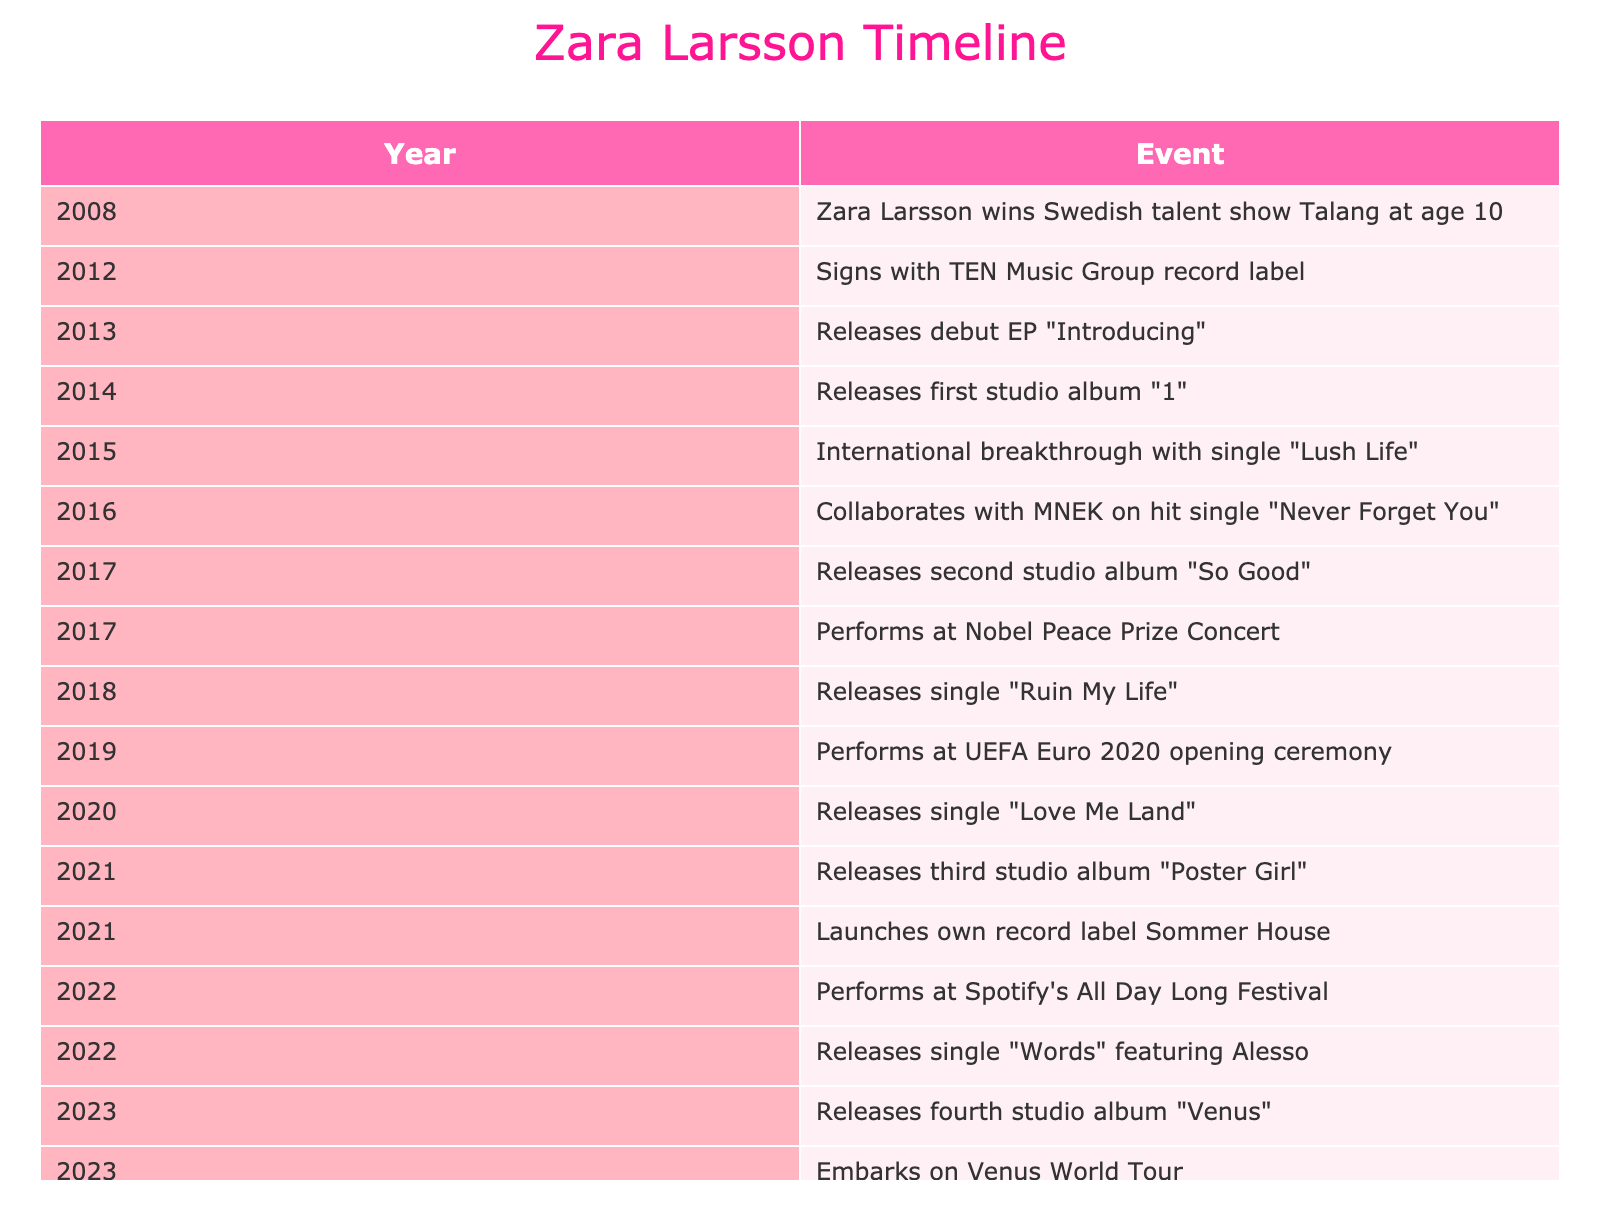What year did Zara Larsson release her first studio album? The table indicates that Zara Larsson released her first studio album titled "1" in the year 2014.
Answer: 2014 What is the title of Zara Larsson's second studio album? According to the table, Zara Larsson's second studio album is titled "So Good," which was released in 2017.
Answer: So Good How many studio albums has Zara Larsson released as of 2023? By reviewing the table, Zara Larsson has released four studio albums: "1" in 2014, "So Good" in 2017, "Poster Girl" in 2021, and "Venus" in 2023. Therefore, the total is four.
Answer: 4 Did Zara Larsson perform at the UEFA Euro 2020 opening ceremony? The table confirms that Zara Larsson did indeed perform at the UEFA Euro 2020 opening ceremony in 2019.
Answer: Yes What year marks Zara Larsson's international breakthrough with the single "Lush Life"? The timeline shows that Zara Larsson experienced her international breakthrough with the single "Lush Life" in 2015.
Answer: 2015 How many years passed between Zara Larsson signing with TEN Music Group and the release of her debut EP? The table shows that Zara Larsson signed with TEN Music Group in 2012 and released her debut EP "Introducing" in 2013. One year passed between the two events.
Answer: 1 year What significant event in Zara Larsson's career took place in 2021? The table lists two significant events for Zara Larsson in 2021: the release of her third studio album "Poster Girl" and the launch of her own record label Sommer House.
Answer: Release of "Poster Girl" and launch of Sommer House Which single featuring Alesso was released by Zara Larsson in 2022? Reviewing the table, it indicates that Zara Larsson released the single "Words" featuring Alesso in 2022.
Answer: Words In which year did Zara Larsson win the Swedish talent show Talang? The table states that Zara Larsson won the Swedish talent show Talang at the young age of 10 in the year 2008.
Answer: 2008 